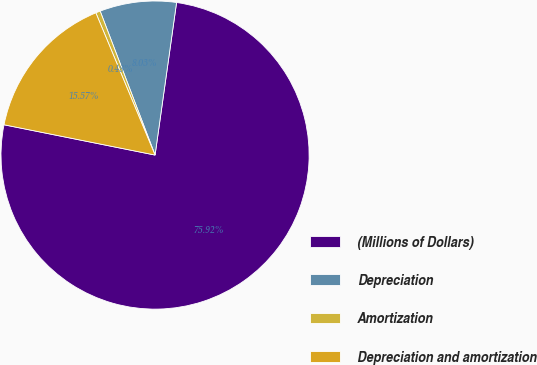Convert chart. <chart><loc_0><loc_0><loc_500><loc_500><pie_chart><fcel>(Millions of Dollars)<fcel>Depreciation<fcel>Amortization<fcel>Depreciation and amortization<nl><fcel>75.92%<fcel>8.03%<fcel>0.48%<fcel>15.57%<nl></chart> 